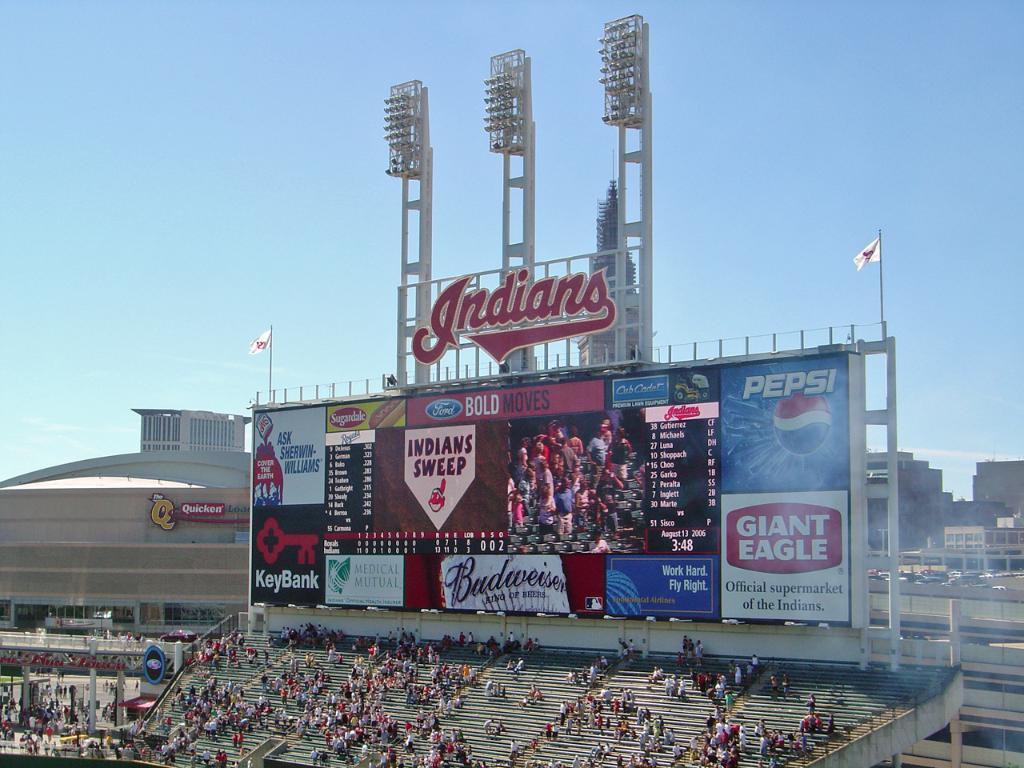What brand of soda is on the board?
Provide a succinct answer. Pepsi. 